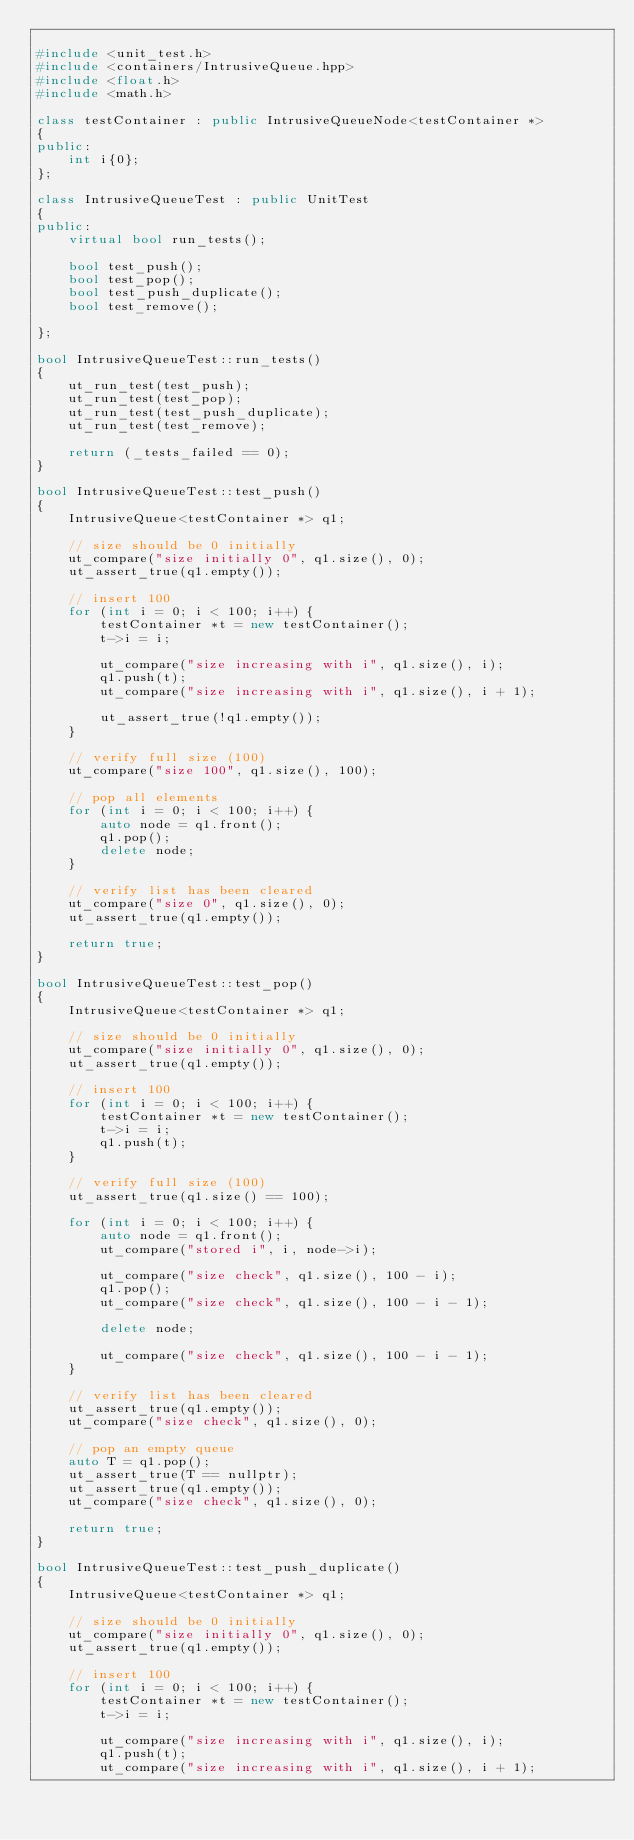Convert code to text. <code><loc_0><loc_0><loc_500><loc_500><_C++_>
#include <unit_test.h>
#include <containers/IntrusiveQueue.hpp>
#include <float.h>
#include <math.h>

class testContainer : public IntrusiveQueueNode<testContainer *>
{
public:
	int i{0};
};

class IntrusiveQueueTest : public UnitTest
{
public:
	virtual bool run_tests();

	bool test_push();
	bool test_pop();
	bool test_push_duplicate();
	bool test_remove();

};

bool IntrusiveQueueTest::run_tests()
{
	ut_run_test(test_push);
	ut_run_test(test_pop);
	ut_run_test(test_push_duplicate);
	ut_run_test(test_remove);

	return (_tests_failed == 0);
}

bool IntrusiveQueueTest::test_push()
{
	IntrusiveQueue<testContainer *> q1;

	// size should be 0 initially
	ut_compare("size initially 0", q1.size(), 0);
	ut_assert_true(q1.empty());

	// insert 100
	for (int i = 0; i < 100; i++) {
		testContainer *t = new testContainer();
		t->i = i;

		ut_compare("size increasing with i", q1.size(), i);
		q1.push(t);
		ut_compare("size increasing with i", q1.size(), i + 1);

		ut_assert_true(!q1.empty());
	}

	// verify full size (100)
	ut_compare("size 100", q1.size(), 100);

	// pop all elements
	for (int i = 0; i < 100; i++) {
		auto node = q1.front();
		q1.pop();
		delete node;
	}

	// verify list has been cleared
	ut_compare("size 0", q1.size(), 0);
	ut_assert_true(q1.empty());

	return true;
}

bool IntrusiveQueueTest::test_pop()
{
	IntrusiveQueue<testContainer *> q1;

	// size should be 0 initially
	ut_compare("size initially 0", q1.size(), 0);
	ut_assert_true(q1.empty());

	// insert 100
	for (int i = 0; i < 100; i++) {
		testContainer *t = new testContainer();
		t->i = i;
		q1.push(t);
	}

	// verify full size (100)
	ut_assert_true(q1.size() == 100);

	for (int i = 0; i < 100; i++) {
		auto node = q1.front();
		ut_compare("stored i", i, node->i);

		ut_compare("size check", q1.size(), 100 - i);
		q1.pop();
		ut_compare("size check", q1.size(), 100 - i - 1);

		delete node;

		ut_compare("size check", q1.size(), 100 - i - 1);
	}

	// verify list has been cleared
	ut_assert_true(q1.empty());
	ut_compare("size check", q1.size(), 0);

	// pop an empty queue
	auto T = q1.pop();
	ut_assert_true(T == nullptr);
	ut_assert_true(q1.empty());
	ut_compare("size check", q1.size(), 0);

	return true;
}

bool IntrusiveQueueTest::test_push_duplicate()
{
	IntrusiveQueue<testContainer *> q1;

	// size should be 0 initially
	ut_compare("size initially 0", q1.size(), 0);
	ut_assert_true(q1.empty());

	// insert 100
	for (int i = 0; i < 100; i++) {
		testContainer *t = new testContainer();
		t->i = i;

		ut_compare("size increasing with i", q1.size(), i);
		q1.push(t);
		ut_compare("size increasing with i", q1.size(), i + 1);
</code> 